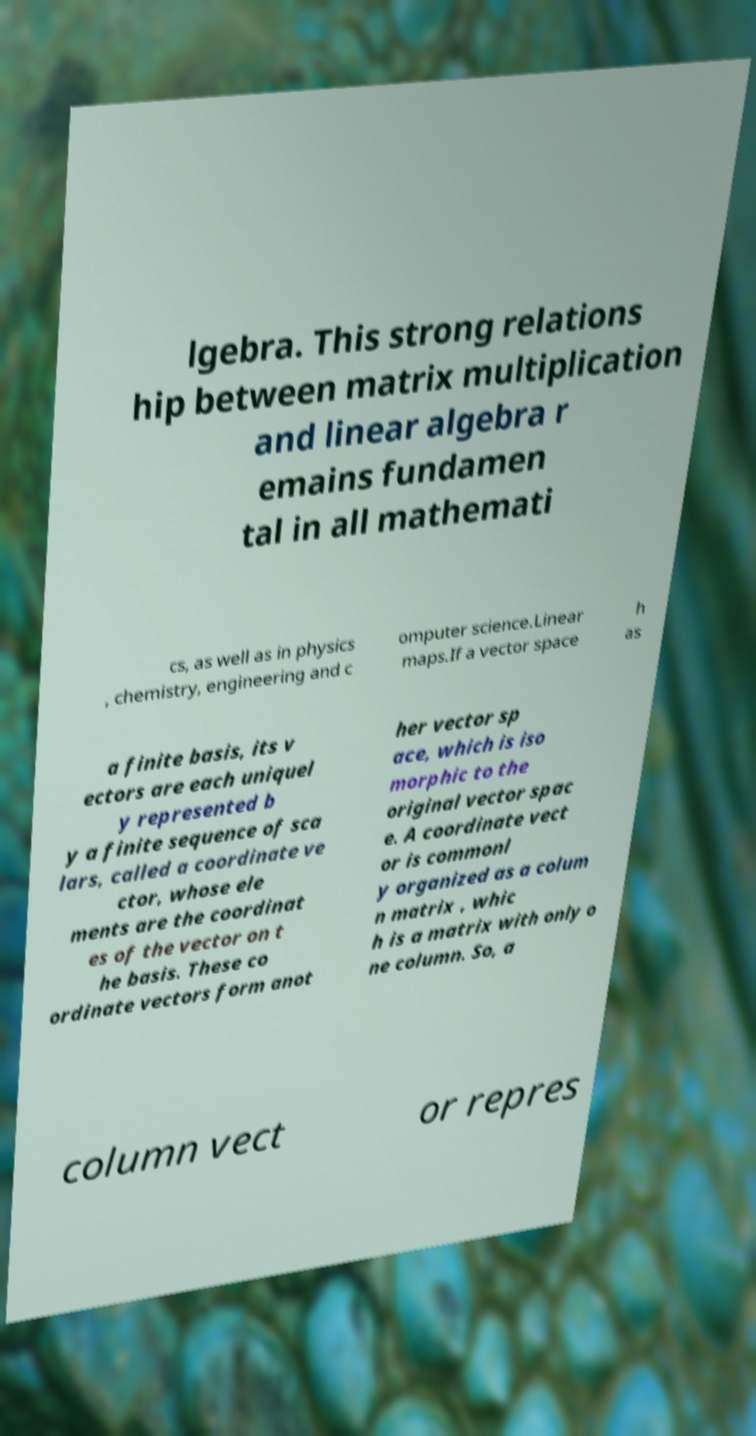Could you extract and type out the text from this image? lgebra. This strong relations hip between matrix multiplication and linear algebra r emains fundamen tal in all mathemati cs, as well as in physics , chemistry, engineering and c omputer science.Linear maps.If a vector space h as a finite basis, its v ectors are each uniquel y represented b y a finite sequence of sca lars, called a coordinate ve ctor, whose ele ments are the coordinat es of the vector on t he basis. These co ordinate vectors form anot her vector sp ace, which is iso morphic to the original vector spac e. A coordinate vect or is commonl y organized as a colum n matrix , whic h is a matrix with only o ne column. So, a column vect or repres 